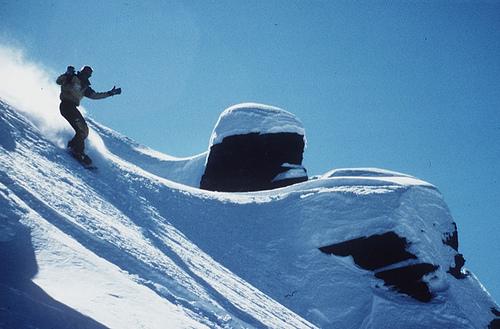Is the person going up or down?
Short answer required. Down. What sport is this person engaged in?
Concise answer only. Snowboarding. What is the person standing o?
Keep it brief. Snowboard. 